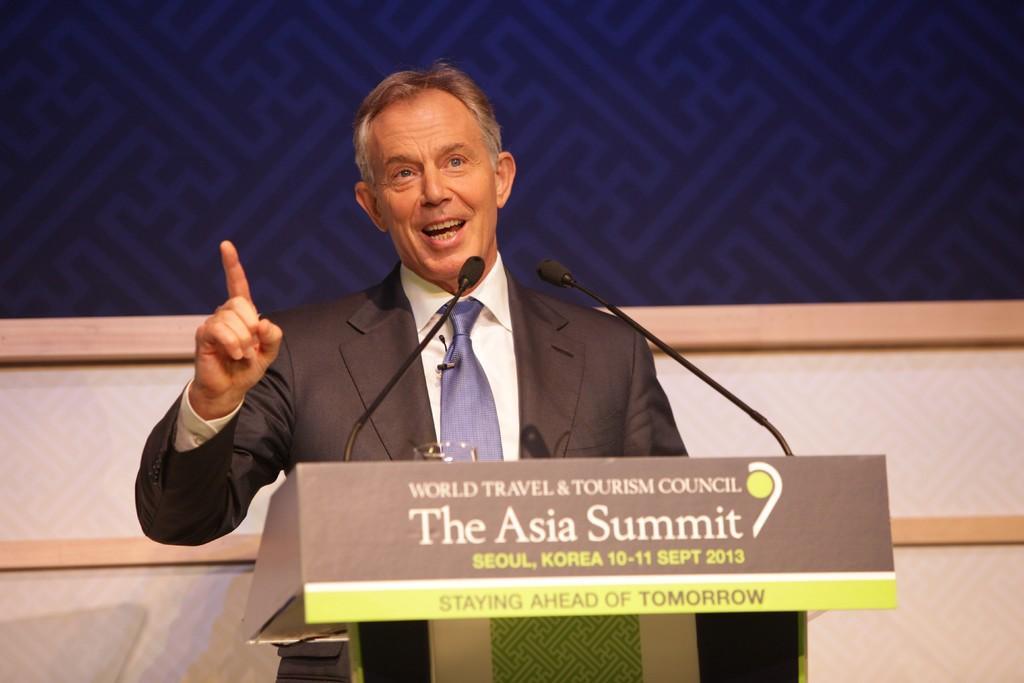How would you summarize this image in a sentence or two? In this image we can see a person standing in front of the podium, on the podium there are two mics and a glass, also the background looks like the wall. 